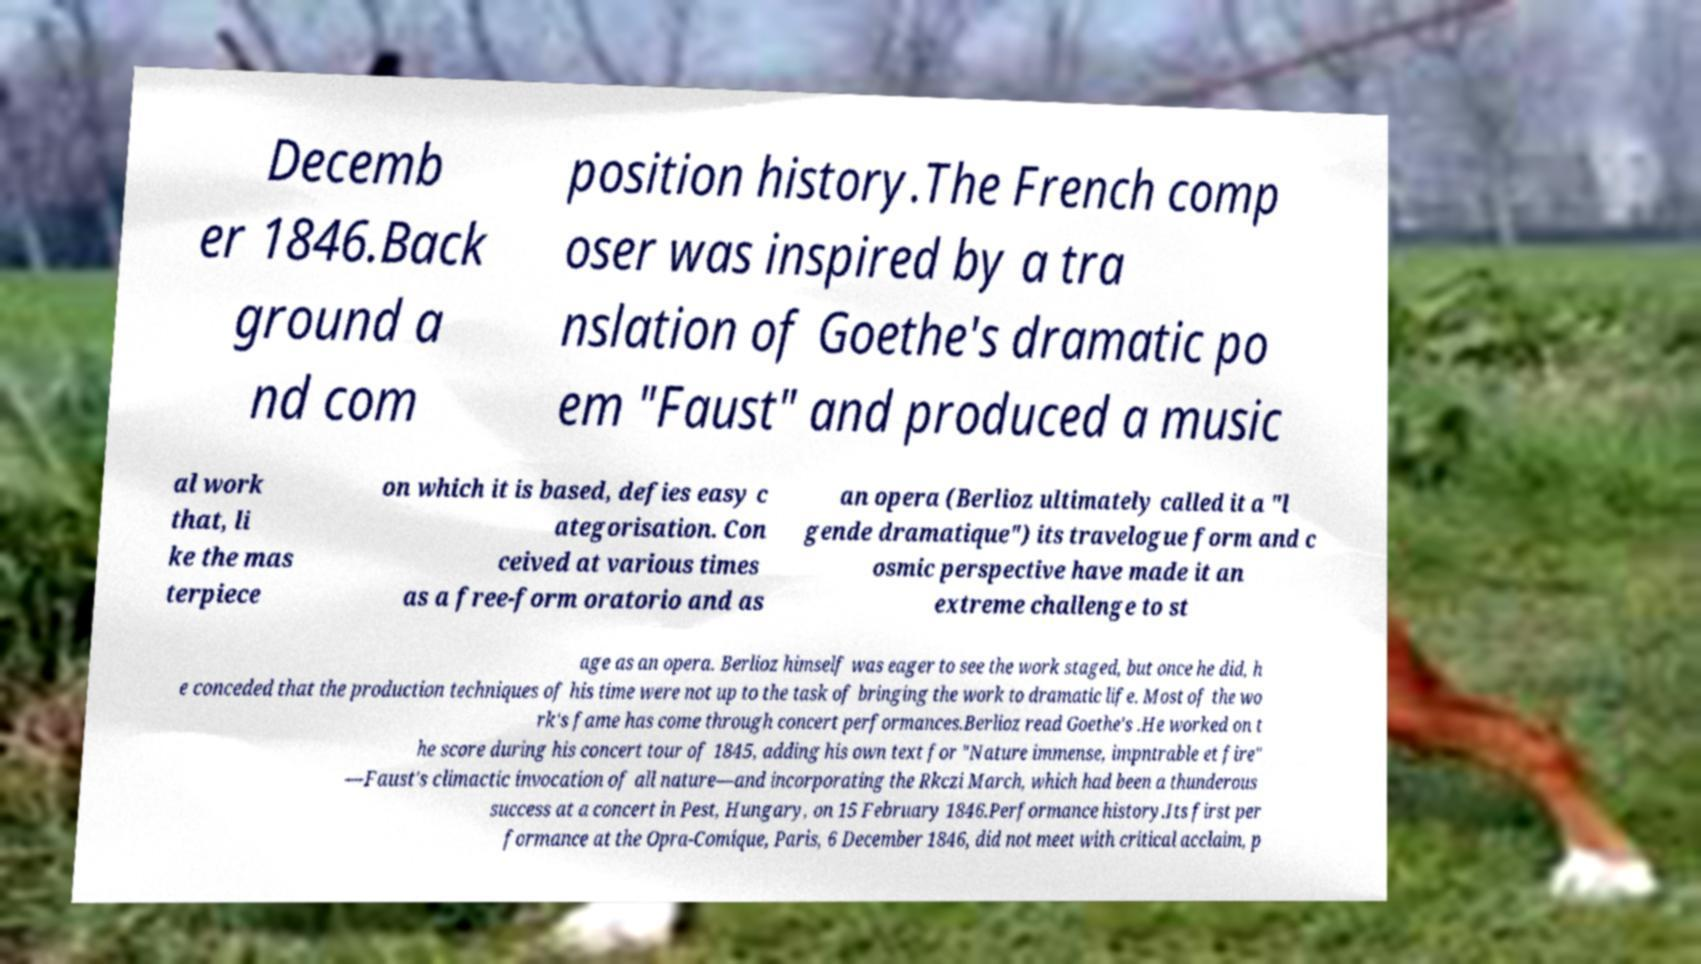Please read and relay the text visible in this image. What does it say? Decemb er 1846.Back ground a nd com position history.The French comp oser was inspired by a tra nslation of Goethe's dramatic po em "Faust" and produced a music al work that, li ke the mas terpiece on which it is based, defies easy c ategorisation. Con ceived at various times as a free-form oratorio and as an opera (Berlioz ultimately called it a "l gende dramatique") its travelogue form and c osmic perspective have made it an extreme challenge to st age as an opera. Berlioz himself was eager to see the work staged, but once he did, h e conceded that the production techniques of his time were not up to the task of bringing the work to dramatic life. Most of the wo rk's fame has come through concert performances.Berlioz read Goethe's .He worked on t he score during his concert tour of 1845, adding his own text for "Nature immense, impntrable et fire" —Faust's climactic invocation of all nature—and incorporating the Rkczi March, which had been a thunderous success at a concert in Pest, Hungary, on 15 February 1846.Performance history.Its first per formance at the Opra-Comique, Paris, 6 December 1846, did not meet with critical acclaim, p 